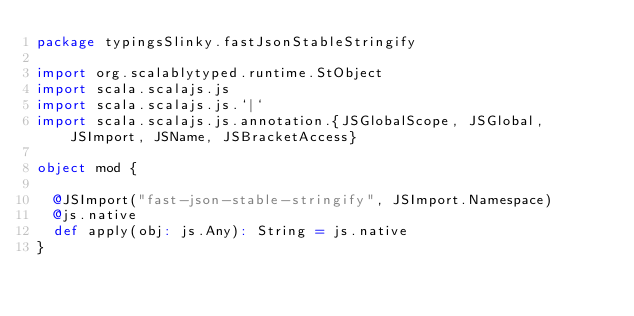Convert code to text. <code><loc_0><loc_0><loc_500><loc_500><_Scala_>package typingsSlinky.fastJsonStableStringify

import org.scalablytyped.runtime.StObject
import scala.scalajs.js
import scala.scalajs.js.`|`
import scala.scalajs.js.annotation.{JSGlobalScope, JSGlobal, JSImport, JSName, JSBracketAccess}

object mod {
  
  @JSImport("fast-json-stable-stringify", JSImport.Namespace)
  @js.native
  def apply(obj: js.Any): String = js.native
}
</code> 